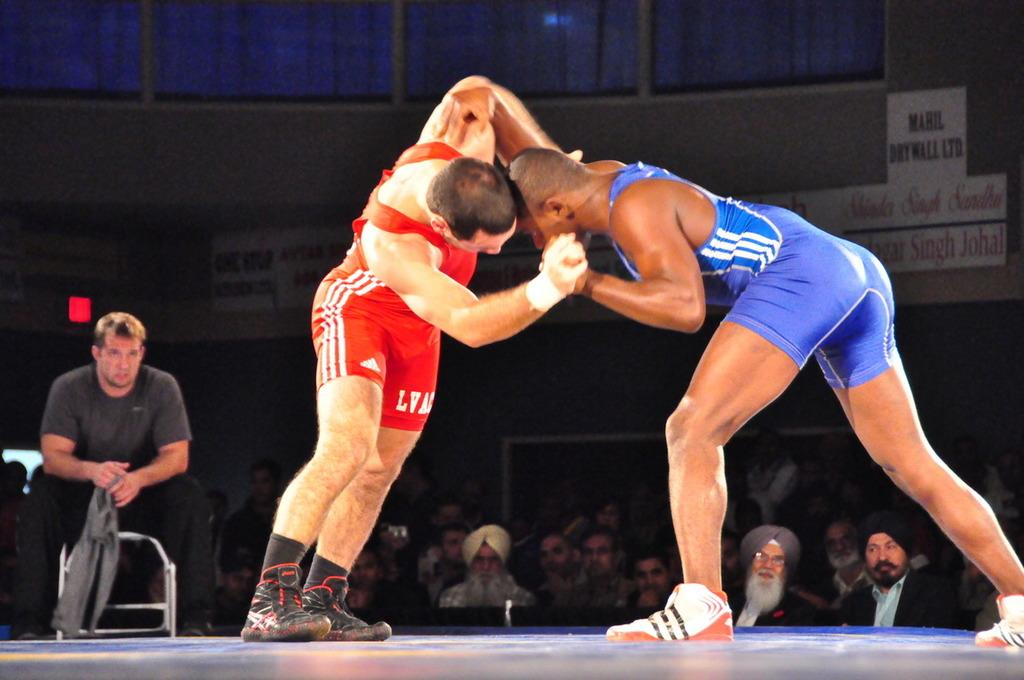<image>
Share a concise interpretation of the image provided. a pair of shorts that has LVA on it 